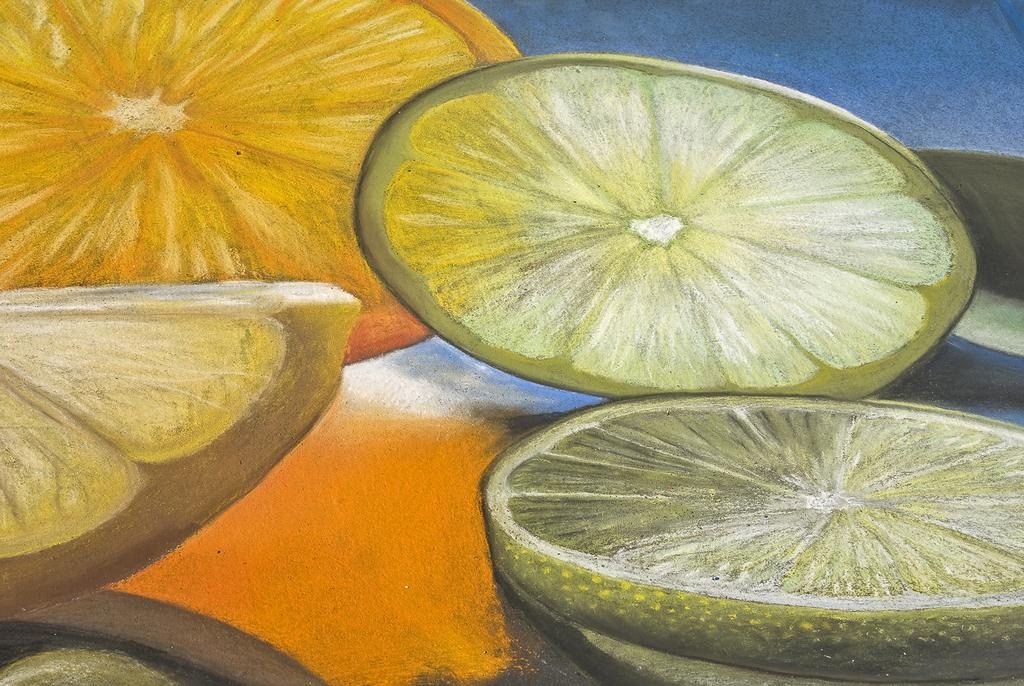What is the main subject of the image? The image contains a painting. What is depicted in the painting? The painting depicts lemon slices. What color is the background of the painting? The background of the painting is blue. What type of door is featured in the painting? There is no door present in the painting; it depicts lemon slices with a blue background. 